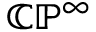<formula> <loc_0><loc_0><loc_500><loc_500>\mathbb { C P } ^ { \infty }</formula> 